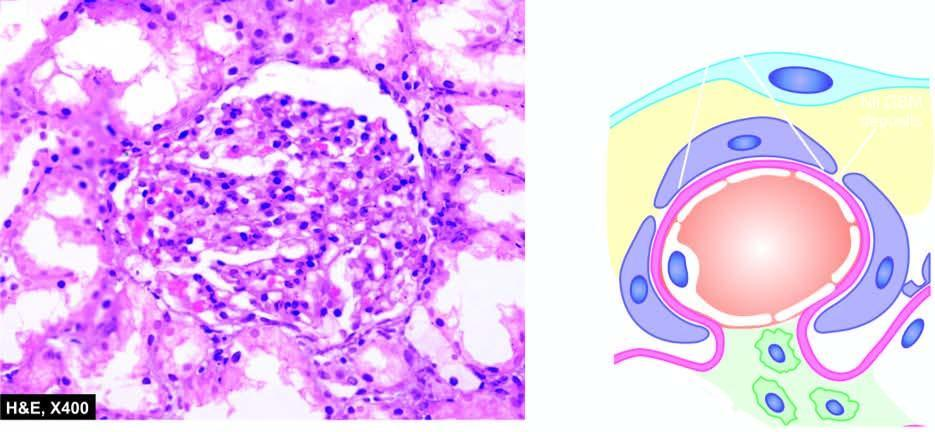s the apex normal?
Answer the question using a single word or phrase. No 